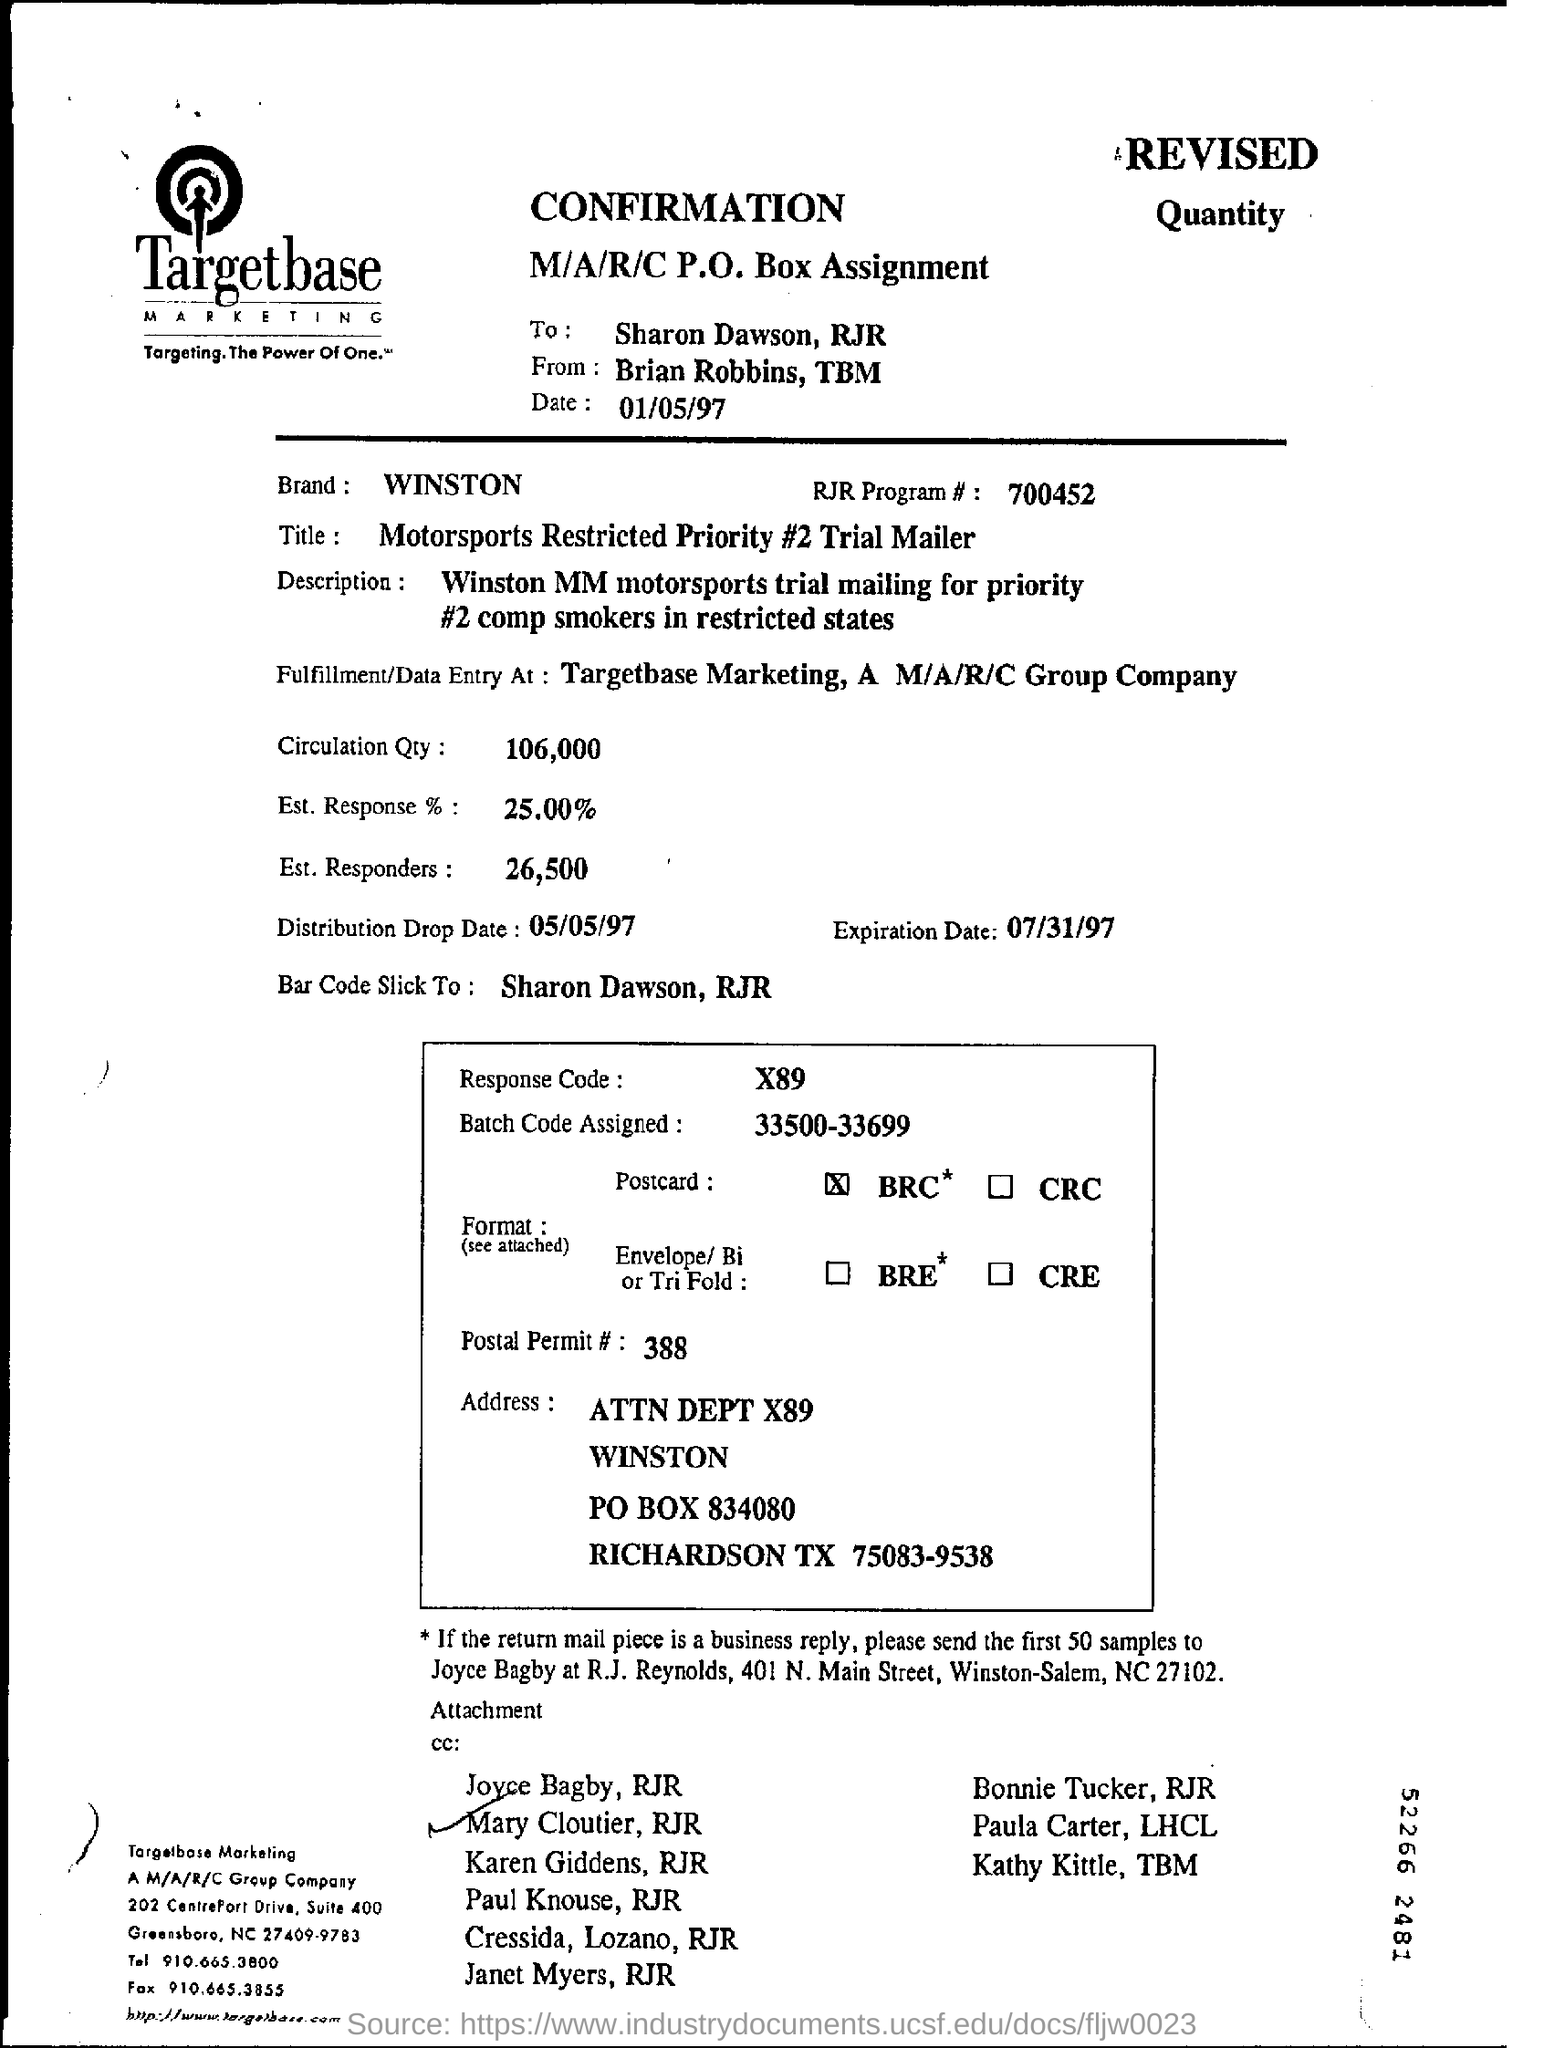What is the Brand name?
Offer a terse response. Winston. Whose name is ticked at the bottom of the page?
Offer a terse response. Mary Cloutier. What is the Expiration Date?
Provide a succinct answer. 07/31/97. 